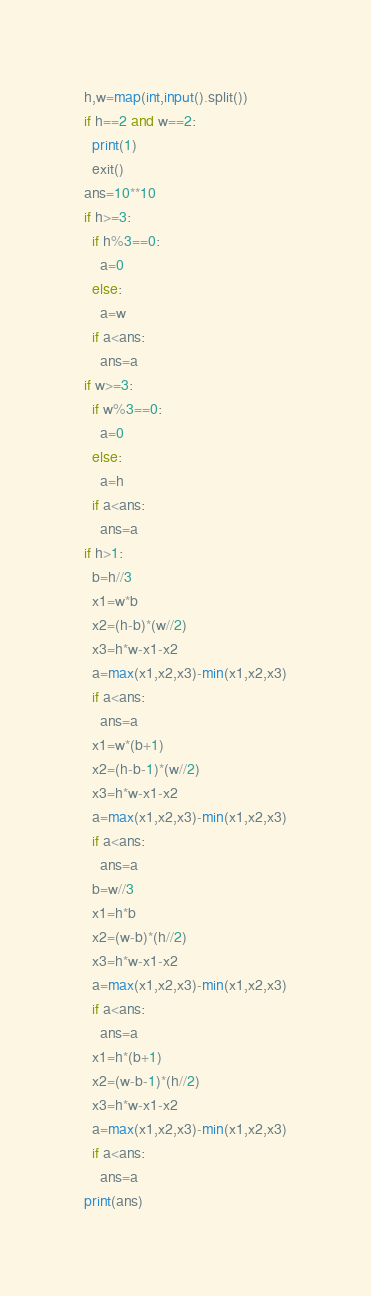Convert code to text. <code><loc_0><loc_0><loc_500><loc_500><_Python_>h,w=map(int,input().split())
if h==2 and w==2:
  print(1)
  exit()
ans=10**10
if h>=3:
  if h%3==0:
    a=0
  else:
    a=w
  if a<ans:
    ans=a
if w>=3:
  if w%3==0:
    a=0
  else:
    a=h
  if a<ans:
    ans=a
if h>1:
  b=h//3
  x1=w*b
  x2=(h-b)*(w//2)
  x3=h*w-x1-x2
  a=max(x1,x2,x3)-min(x1,x2,x3)
  if a<ans:
    ans=a
  x1=w*(b+1)
  x2=(h-b-1)*(w//2)
  x3=h*w-x1-x2
  a=max(x1,x2,x3)-min(x1,x2,x3)
  if a<ans:
    ans=a
  b=w//3
  x1=h*b
  x2=(w-b)*(h//2)
  x3=h*w-x1-x2
  a=max(x1,x2,x3)-min(x1,x2,x3)
  if a<ans:
    ans=a
  x1=h*(b+1)
  x2=(w-b-1)*(h//2)
  x3=h*w-x1-x2
  a=max(x1,x2,x3)-min(x1,x2,x3)
  if a<ans:
    ans=a
print(ans)</code> 